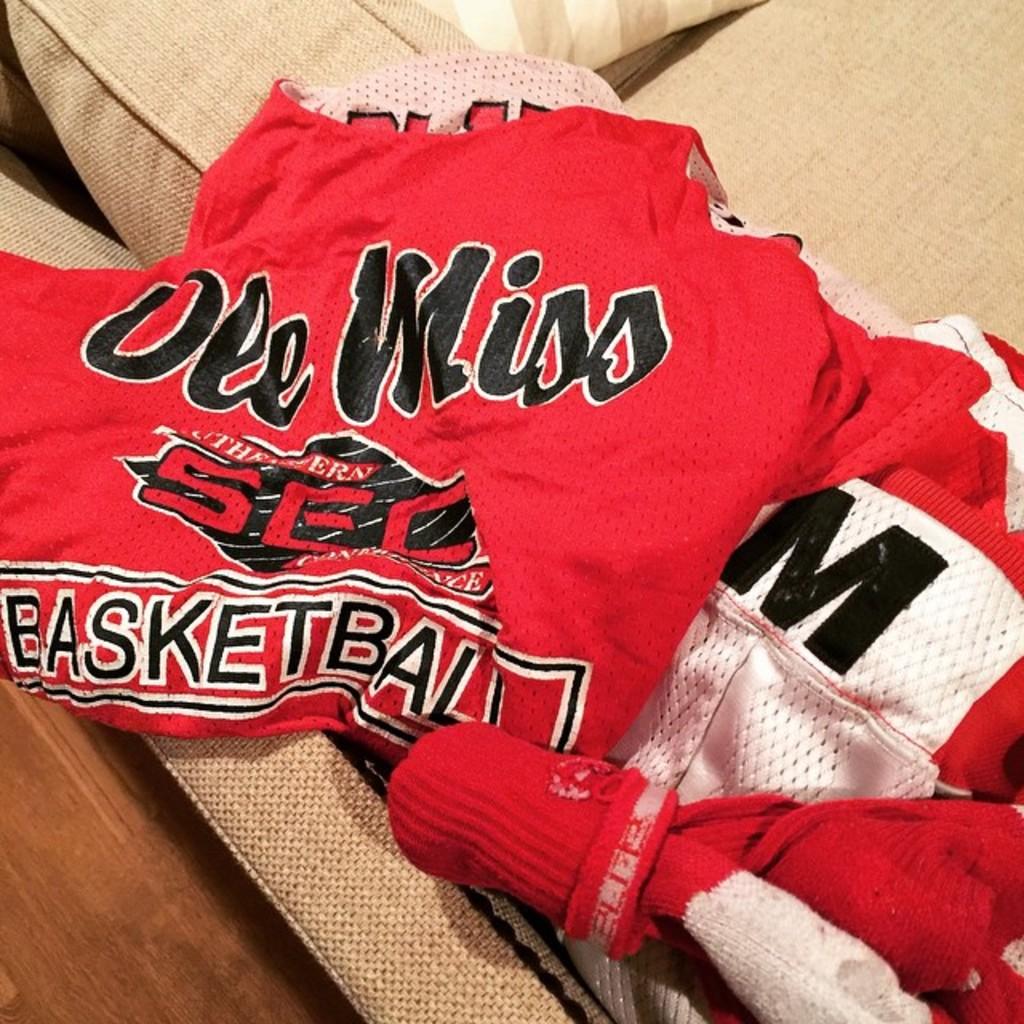What team is this?
Make the answer very short. Ole miss. 